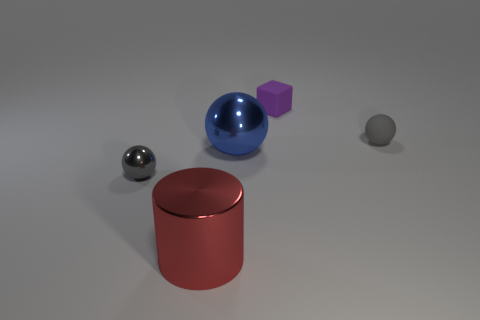What size is the red object?
Keep it short and to the point. Large. Are there any metal balls that have the same color as the small rubber ball?
Your answer should be very brief. Yes. There is a gray thing that is in front of the blue object; is it the same shape as the big thing that is right of the red cylinder?
Offer a very short reply. Yes. How many other things are the same size as the purple thing?
Provide a succinct answer. 2. Do the small rubber sphere and the tiny object to the left of the purple rubber block have the same color?
Ensure brevity in your answer.  Yes. Is the number of things right of the small purple matte object less than the number of spheres on the right side of the large red thing?
Your response must be concise. Yes. What is the color of the object that is on the left side of the rubber sphere and right of the large metallic ball?
Keep it short and to the point. Purple. There is a blue object; does it have the same size as the gray object that is on the left side of the small matte block?
Your response must be concise. No. What is the shape of the large thing that is to the right of the large cylinder?
Ensure brevity in your answer.  Sphere. Are there more tiny metallic things in front of the cube than tiny purple metallic cubes?
Keep it short and to the point. Yes. 